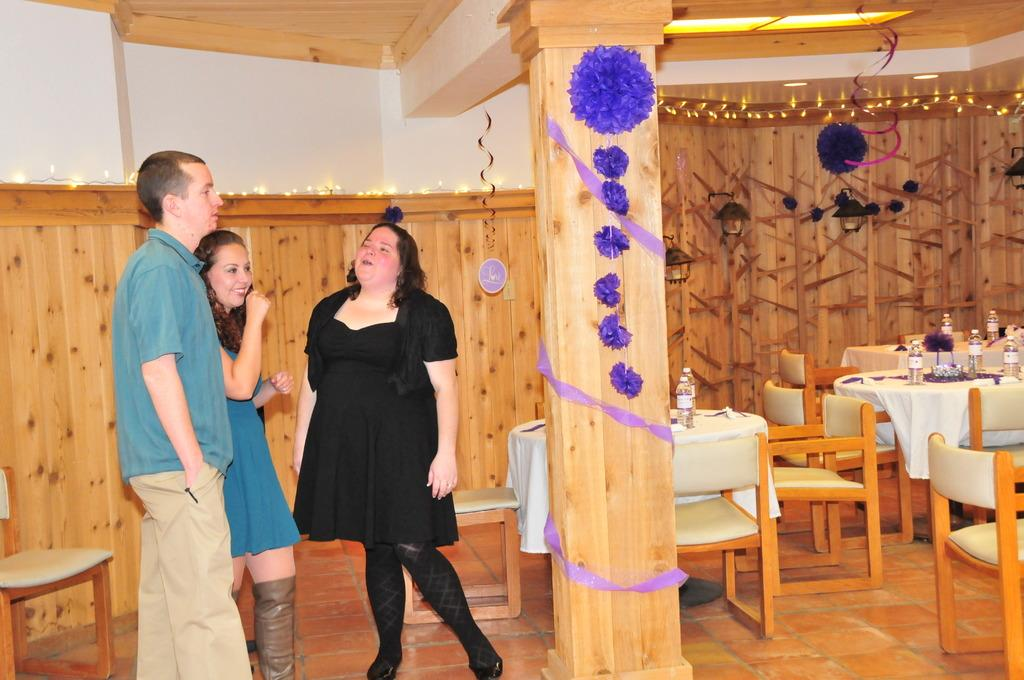How many people are in the room in the image? There are two women and a man in the room. What can be seen on the tables in the room? There are water bottles and a flower vase on the tables. What type of furniture is in the room? There are chairs in the room. What type of decoration is present in the room? Decorated lights are present in the room. What is a part of the room's structure? There is a wall in the room. What type of thread is being used to sew the man's toes in the image? There is no indication in the image that the man's toes are being sewn or that any thread is present. 